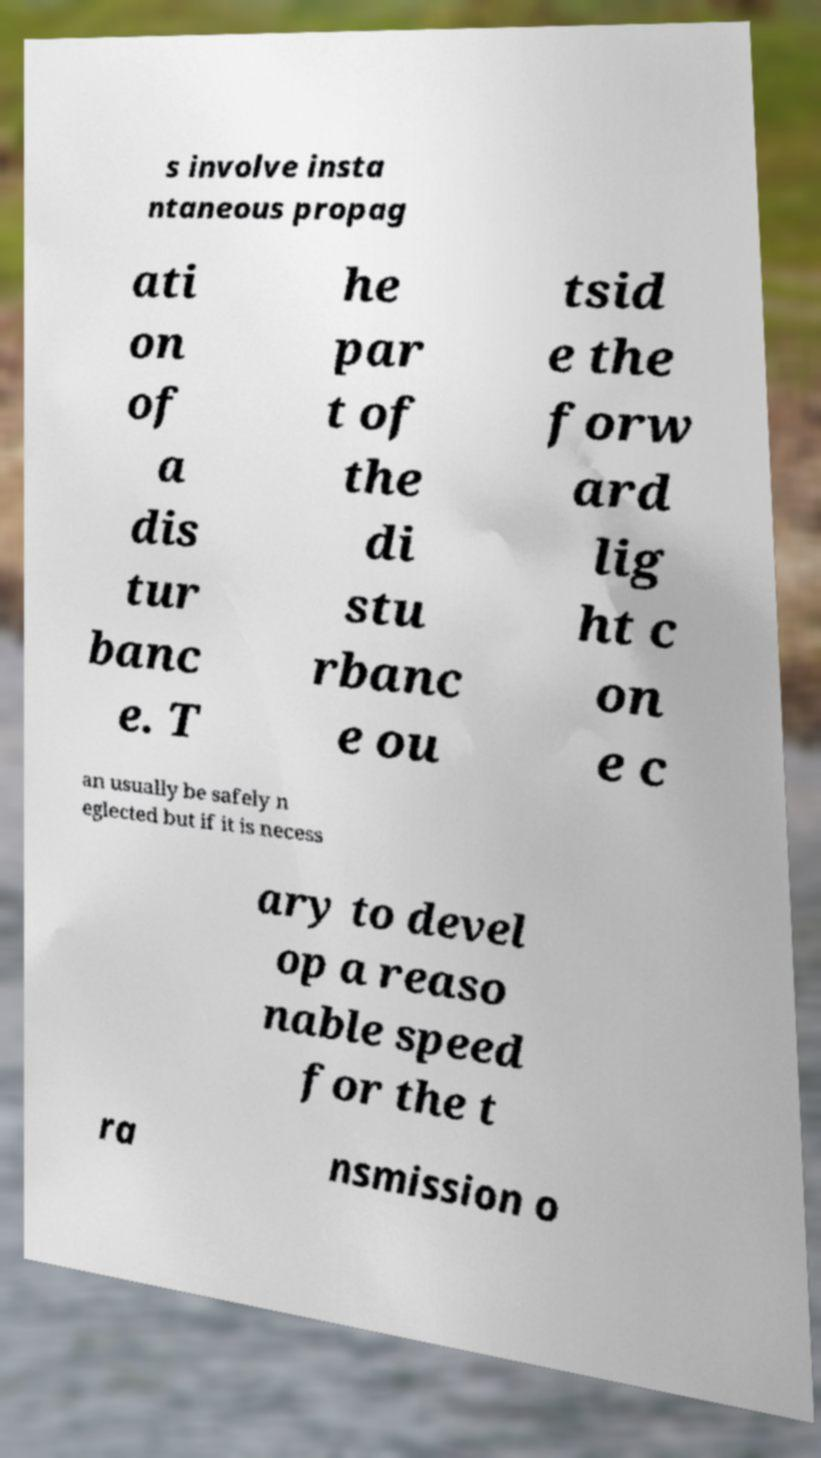Could you extract and type out the text from this image? s involve insta ntaneous propag ati on of a dis tur banc e. T he par t of the di stu rbanc e ou tsid e the forw ard lig ht c on e c an usually be safely n eglected but if it is necess ary to devel op a reaso nable speed for the t ra nsmission o 